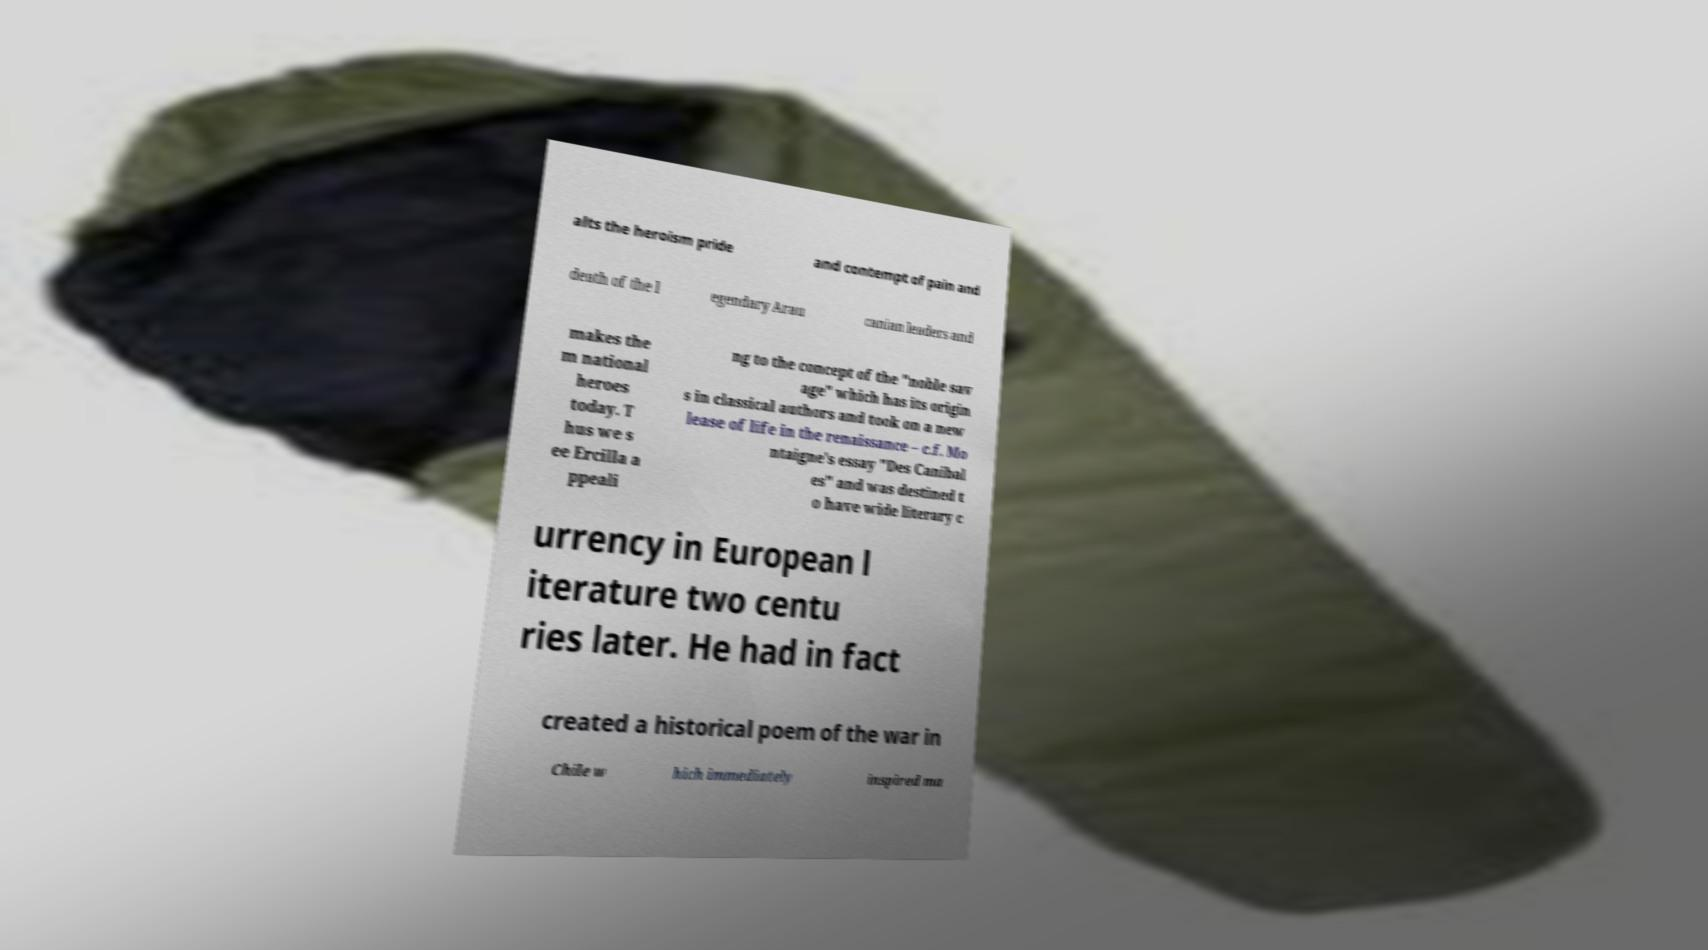There's text embedded in this image that I need extracted. Can you transcribe it verbatim? alts the heroism pride and contempt of pain and death of the l egendary Arau canian leaders and makes the m national heroes today. T hus we s ee Ercilla a ppeali ng to the concept of the "noble sav age" which has its origin s in classical authors and took on a new lease of life in the renaissance – c.f. Mo ntaigne's essay "Des Canibal es" and was destined t o have wide literary c urrency in European l iterature two centu ries later. He had in fact created a historical poem of the war in Chile w hich immediately inspired ma 